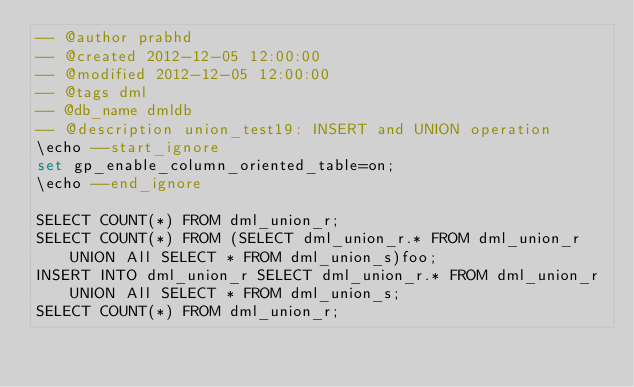<code> <loc_0><loc_0><loc_500><loc_500><_SQL_>-- @author prabhd 
-- @created 2012-12-05 12:00:00 
-- @modified 2012-12-05 12:00:00 
-- @tags dml 
-- @db_name dmldb
-- @description union_test19: INSERT and UNION operation
\echo --start_ignore
set gp_enable_column_oriented_table=on;
\echo --end_ignore

SELECT COUNT(*) FROM dml_union_r;
SELECT COUNT(*) FROM (SELECT dml_union_r.* FROM dml_union_r UNION All SELECT * FROM dml_union_s)foo;
INSERT INTO dml_union_r SELECT dml_union_r.* FROM dml_union_r UNION All SELECT * FROM dml_union_s;
SELECT COUNT(*) FROM dml_union_r;

</code> 